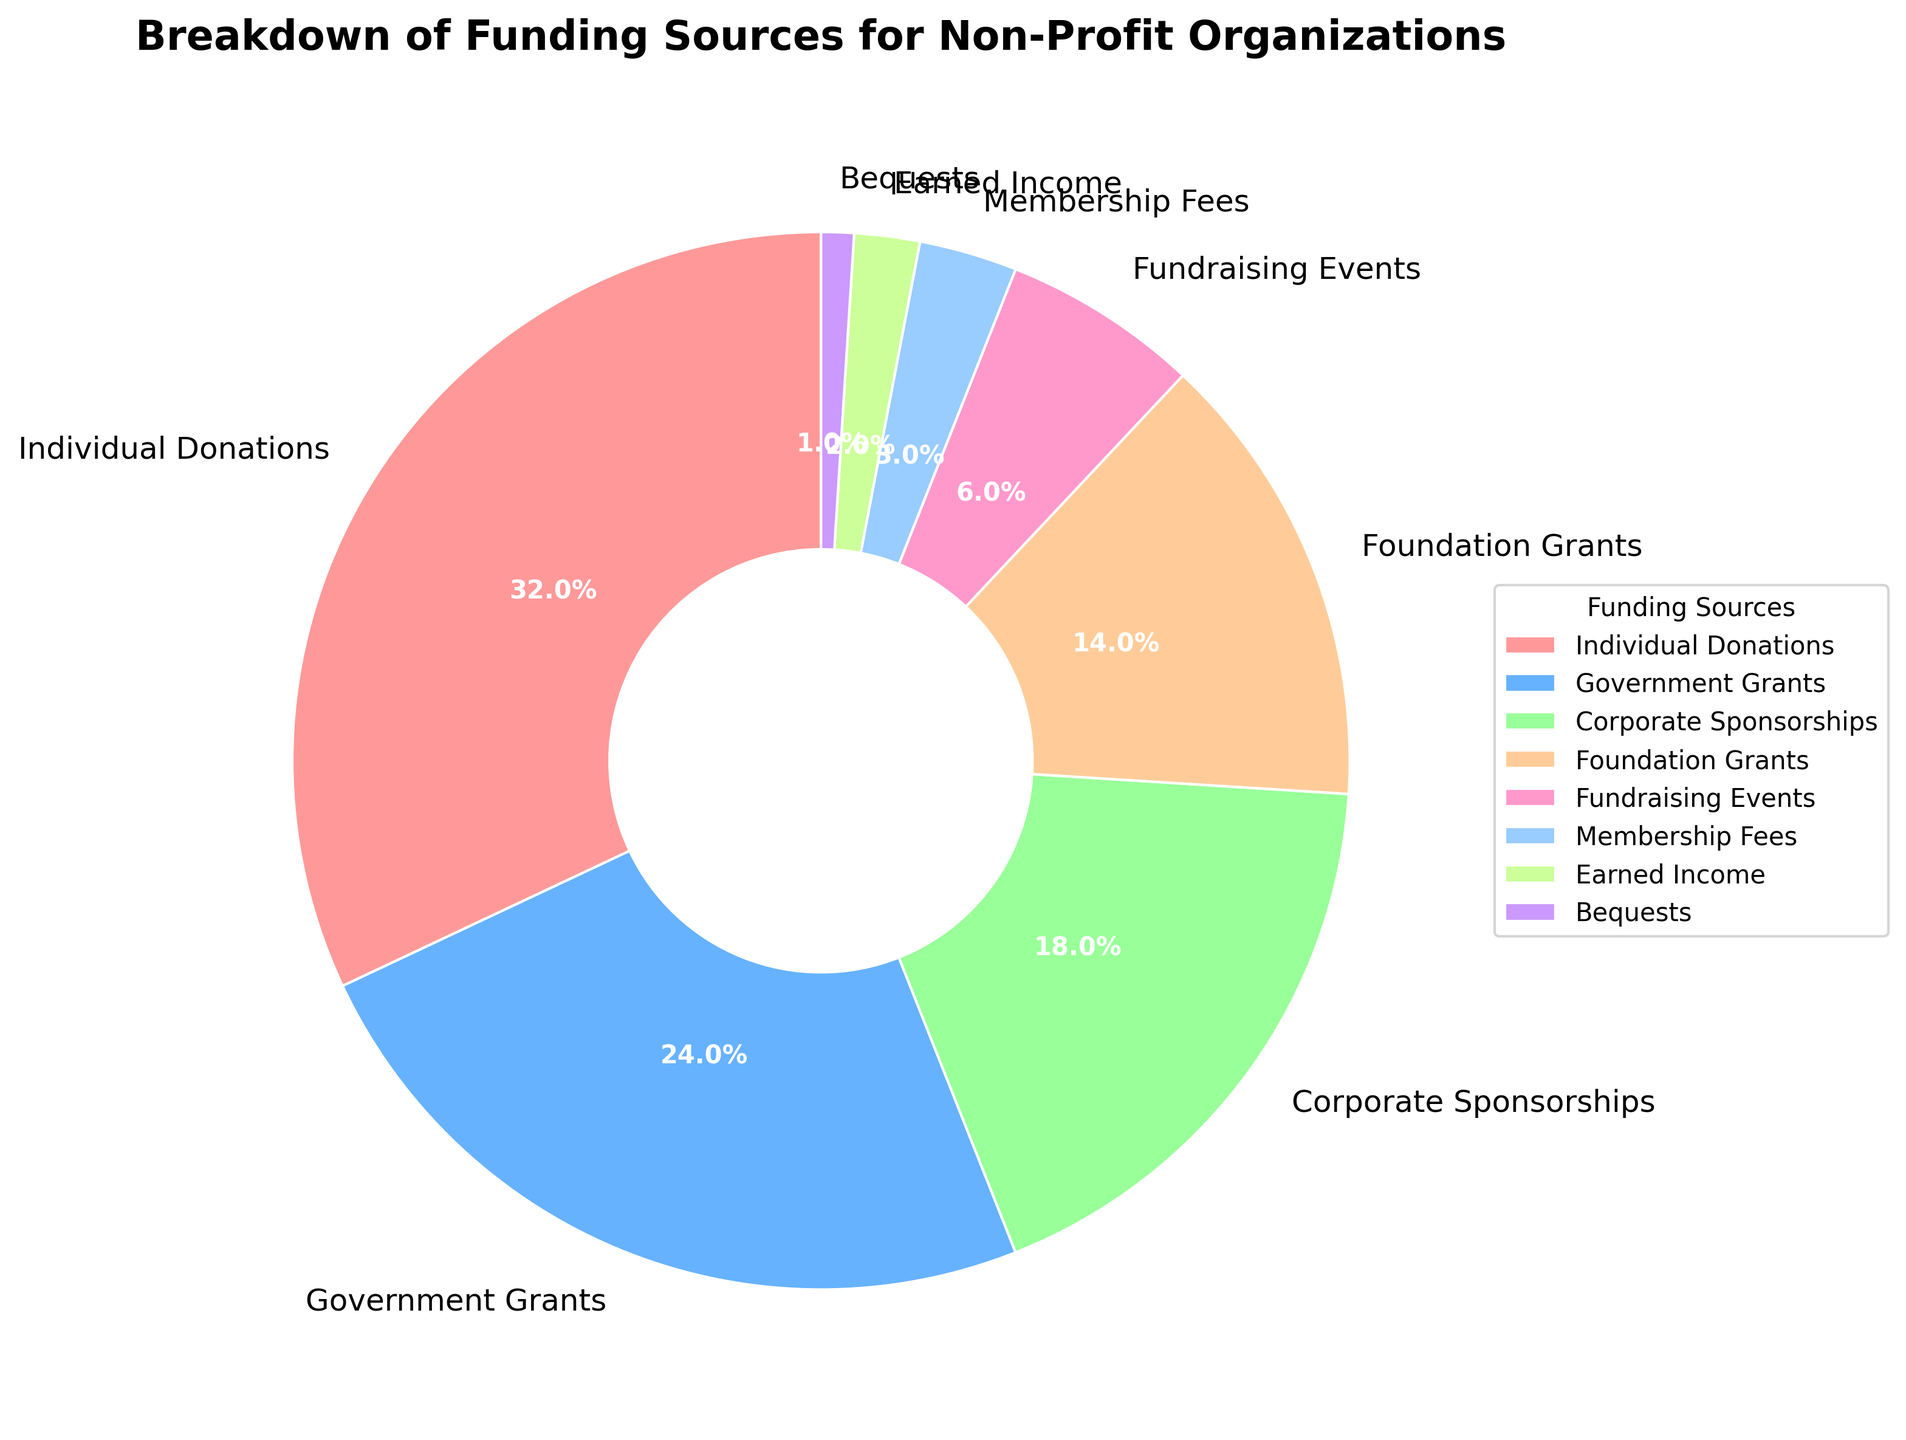What percentage of funding comes from individual donations? The figure shows the breakdown of funding sources for non-profit organizations with the specific percentage values listed. Locate the section for "Individual Donations" in the pie chart.
Answer: 32% Which funding source contributes the smallest percentage? Examine the pie chart to identify the smallest segment, which represents the least contributing funding source.
Answer: Bequests What is the combined percentage of government grants and foundation grants? To find the combined percentage, add the percentage of government grants (24%) and foundation grants (14%) together. 24% + 14% = 38%
Answer: 38% Are individual donations and corporate sponsorships combined more or less than 50% of the total funding? Add the percentage of individual donations (32%) and corporate sponsorships (18%). 32% + 18% = 50%. Since it's exactly 50%, it is equal.
Answer: Equal Which funding source has a higher percentage, fundraising events or earned income? Compare the segments labeled as fundraising events (6%) and earned income (2%) in the pie chart. Fundraising events have a higher percentage.
Answer: Fundraising events What is the difference in percentage between corporate sponsorships and membership fees? Subtract the percentage of membership fees (3%) from the percentage of corporate sponsorships (18%). 18% - 3% = 15%
Answer: 15% What percentage of funding comes from sources other than individual donations and government grants? Subtract the combined percentage of individual donations (32%) and government grants (24%) from 100%. 100% - (32% + 24%) = 44%
Answer: 44% Which funding source is represented by the light blue section in the pie chart? Each section of the pie chart is colored differently. Identify the light blue section and cross-reference it with the legend.
Answer: Government grants Is the percentage of foundation grants greater than the combination of earned income and bequests? Add the percentage of earned income (2%) and bequests (1%). Compare the sum (3%) with the percentage of foundation grants (14%). Yes, 14% is greater than 3%.
Answer: Yes 